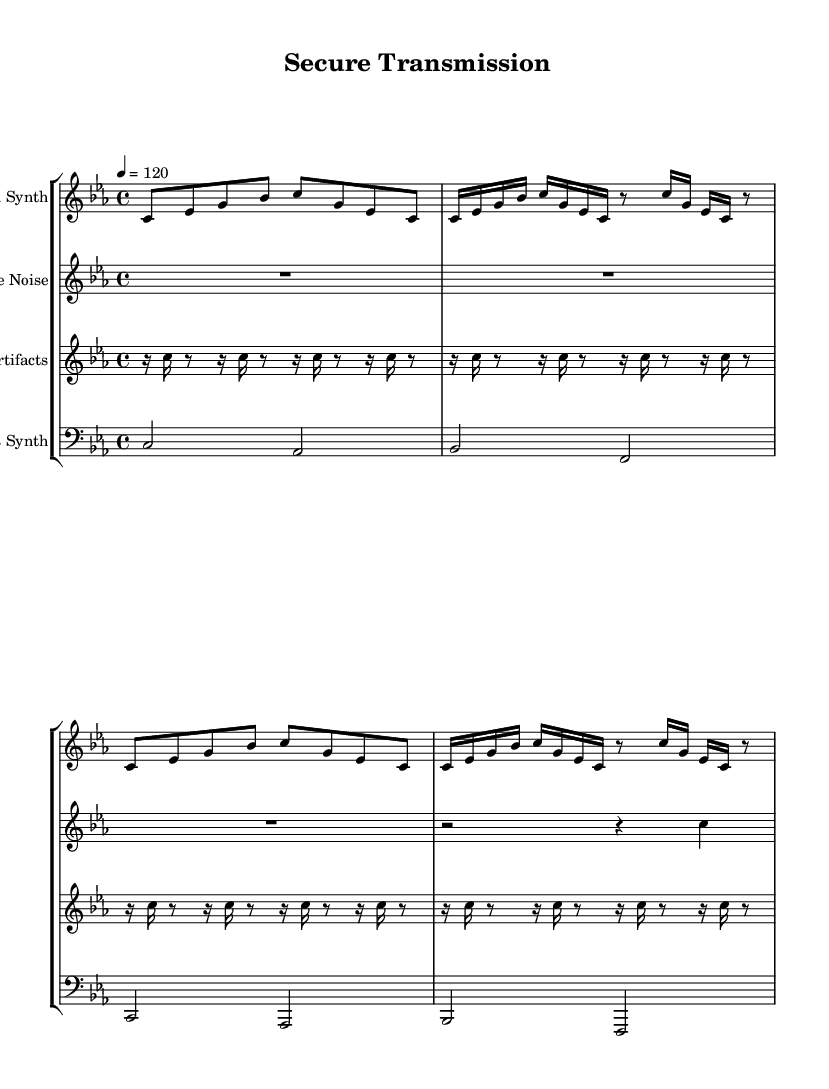What is the key signature of this music? The key signature is C minor, which has three flats: B flat, E flat, and A flat.
Answer: C minor What is the time signature of this music? The time signature is indicated as 4/4, which means there are four beats in a measure and the quarter note gets one beat.
Answer: 4/4 What is the tempo marking for this composition? The tempo marking is set to "4 = 120," meaning the quarter note should be played at a speed of 120 beats per minute.
Answer: 120 How many measures does the glitch synth section consist of? The glitch synth section has four measures, as there are four distinct phrases of music separated by bars.
Answer: 4 measures What two main elements distinguish the white noise part? The white noise part primarily consists of rests for three beats followed by a glissando on a quarter note, indicating sound blended with silence.
Answer: Rests and glissando What is the rhythmic pattern of the digital artifacts section? The digital artifacts section has a repetitive rhythmic pattern, alternating between sixteenth notes and eighth notes, creating a glitchy effect.
Answer: Repetitive alternating pattern What type of sound does the bass synth produce throughout the piece? The bass synth predominantly produces sustained notes in a lower range, providing a contrast to the higher-pitched glitch and noise sections.
Answer: Sustained lower notes 